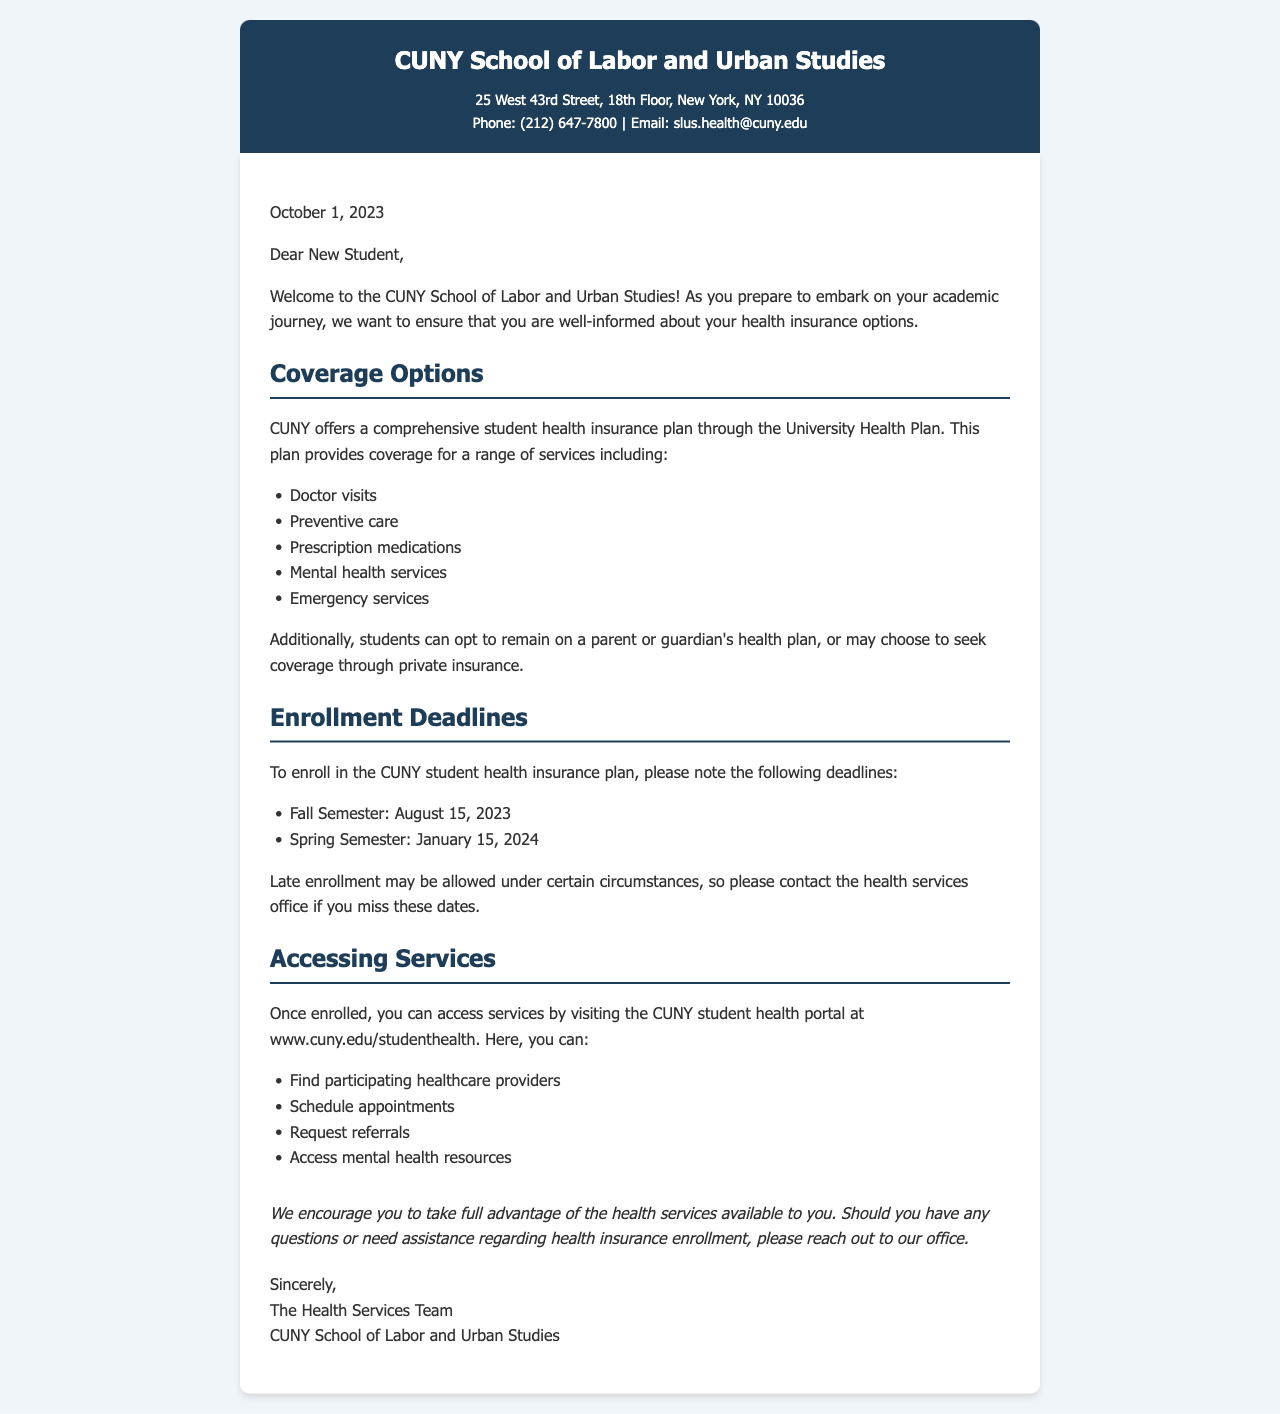What information is provided about health coverage options? The document outlines that CUNY offers a comprehensive student health insurance plan through the University Health Plan, covering services like doctor visits, preventive care, and more.
Answer: comprehensive student health insurance plan What is the deadline for the Fall Semester enrollment? The document specifies that the enrollment deadline for the Fall Semester is August 15, 2023.
Answer: August 15, 2023 What is the contact email for health services? The document provides the contact email for health services as slus.health@cuny.edu.
Answer: slus.health@cuny.edu What services can you access through the CUNY student health portal? The document lists services such as finding providers, scheduling appointments, and accessing mental health resources.
Answer: find participating healthcare providers What should students do if they miss the enrollment deadlines? The document advises students to contact the health services office if they miss these dates for potential late enrollment options.
Answer: contact the health services office Who signs the letter? The closing signs off the letter as The Health Services Team, CUNY School of Labor and Urban Studies.
Answer: The Health Services Team What type of document is this? The letter serves to inform students about health insurance options, enrollment deadlines, and how to access services.
Answer: health insurance information letter 